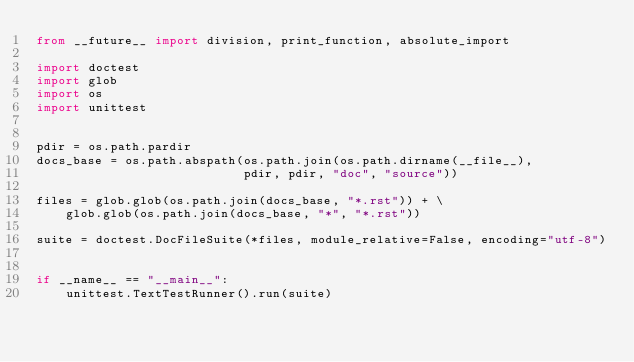<code> <loc_0><loc_0><loc_500><loc_500><_Python_>from __future__ import division, print_function, absolute_import

import doctest
import glob
import os
import unittest


pdir = os.path.pardir
docs_base = os.path.abspath(os.path.join(os.path.dirname(__file__),
                            pdir, pdir, "doc", "source"))

files = glob.glob(os.path.join(docs_base, "*.rst")) + \
    glob.glob(os.path.join(docs_base, "*", "*.rst"))

suite = doctest.DocFileSuite(*files, module_relative=False, encoding="utf-8")


if __name__ == "__main__":
    unittest.TextTestRunner().run(suite)
</code> 